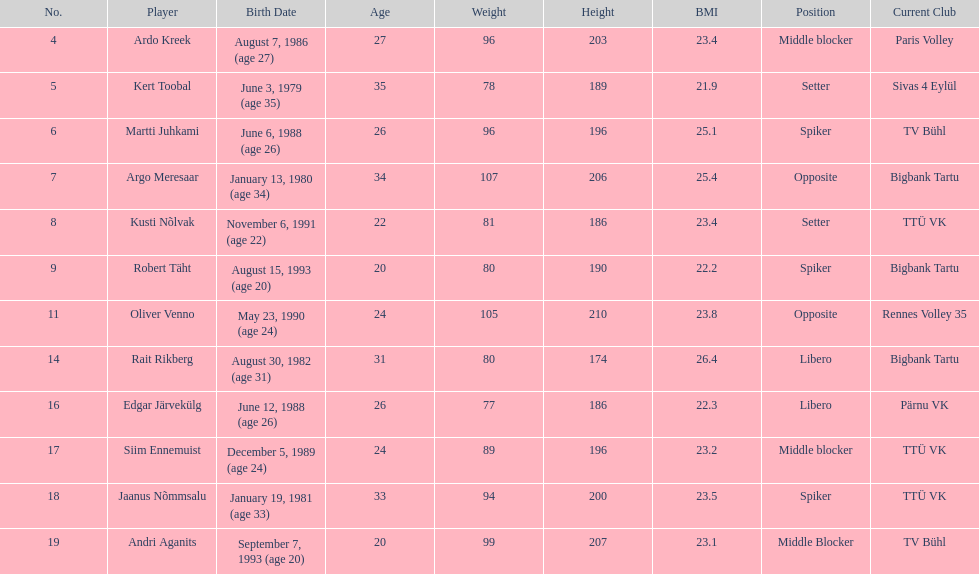How many players are middle blockers? 3. 